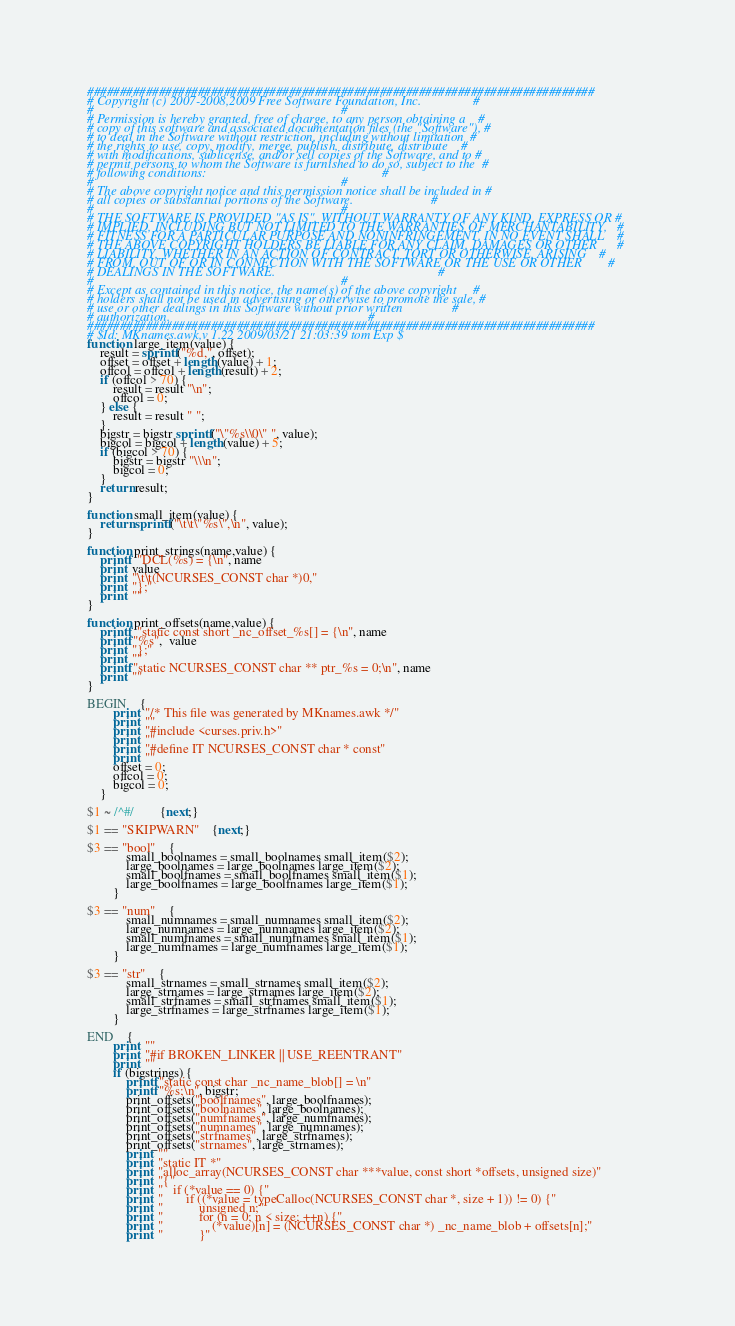Convert code to text. <code><loc_0><loc_0><loc_500><loc_500><_Awk_>##############################################################################
# Copyright (c) 2007-2008,2009 Free Software Foundation, Inc.                #
#                                                                            #
# Permission is hereby granted, free of charge, to any person obtaining a    #
# copy of this software and associated documentation files (the "Software"), #
# to deal in the Software without restriction, including without limitation  #
# the rights to use, copy, modify, merge, publish, distribute, distribute    #
# with modifications, sublicense, and/or sell copies of the Software, and to #
# permit persons to whom the Software is furnished to do so, subject to the  #
# following conditions:                                                      #
#                                                                            #
# The above copyright notice and this permission notice shall be included in #
# all copies or substantial portions of the Software.                        #
#                                                                            #
# THE SOFTWARE IS PROVIDED "AS IS", WITHOUT WARRANTY OF ANY KIND, EXPRESS OR #
# IMPLIED, INCLUDING BUT NOT LIMITED TO THE WARRANTIES OF MERCHANTABILITY,   #
# FITNESS FOR A PARTICULAR PURPOSE AND NONINFRINGEMENT. IN NO EVENT SHALL    #
# THE ABOVE COPYRIGHT HOLDERS BE LIABLE FOR ANY CLAIM, DAMAGES OR OTHER      #
# LIABILITY, WHETHER IN AN ACTION OF CONTRACT, TORT OR OTHERWISE, ARISING    #
# FROM, OUT OF OR IN CONNECTION WITH THE SOFTWARE OR THE USE OR OTHER        #
# DEALINGS IN THE SOFTWARE.                                                  #
#                                                                            #
# Except as contained in this notice, the name(s) of the above copyright     #
# holders shall not be used in advertising or otherwise to promote the sale, #
# use or other dealings in this Software without prior written               #
# authorization.                                                             #
##############################################################################
# $Id: MKnames.awk,v 1.22 2009/03/21 21:03:39 tom Exp $
function large_item(value) {
	result = sprintf("%d,", offset);
	offset = offset + length(value) + 1;
	offcol = offcol + length(result) + 2;
	if (offcol > 70) {
		result = result "\n";
		offcol = 0;
	} else {
		result = result " ";
	}
	bigstr = bigstr sprintf("\"%s\\0\" ", value);
	bigcol = bigcol + length(value) + 5;
	if (bigcol > 70) {
		bigstr = bigstr "\\\n";
		bigcol = 0;
	}
	return result;
}

function small_item(value) {
	return sprintf("\t\t\"%s\",\n", value);
}

function print_strings(name,value) {
	printf  "DCL(%s) = {\n", name
	print  value
	print  "\t\t(NCURSES_CONST char *)0,"
	print  "};"
	print  ""
}

function print_offsets(name,value) {
	printf  "static const short _nc_offset_%s[] = {\n", name
	printf "%s",  value
	print  "};"
	print  ""
	printf "static NCURSES_CONST char ** ptr_%s = 0;\n", name
	print  ""
}

BEGIN	{
		print  "/* This file was generated by MKnames.awk */"
		print  ""
		print  "#include <curses.priv.h>"
		print  ""
		print  "#define IT NCURSES_CONST char * const"
		print  ""
		offset = 0;
		offcol = 0;
		bigcol = 0;
	}

$1 ~ /^#/		{next;}

$1 == "SKIPWARN"	{next;}

$3 == "bool"	{
			small_boolnames = small_boolnames small_item($2);
			large_boolnames = large_boolnames large_item($2);
			small_boolfnames = small_boolfnames small_item($1);
			large_boolfnames = large_boolfnames large_item($1);
		}

$3 == "num"	{
			small_numnames = small_numnames small_item($2);
			large_numnames = large_numnames large_item($2);
			small_numfnames = small_numfnames small_item($1);
			large_numfnames = large_numfnames large_item($1);
		}

$3 == "str"	{
			small_strnames = small_strnames small_item($2);
			large_strnames = large_strnames large_item($2);
			small_strfnames = small_strfnames small_item($1);
			large_strfnames = large_strfnames large_item($1);
		}

END	{
		print  ""
		print  "#if BROKEN_LINKER || USE_REENTRANT"
		print  ""
		if (bigstrings) {
			printf "static const char _nc_name_blob[] = \n"
			printf "%s;\n", bigstr;
			print_offsets("boolfnames", large_boolfnames);
			print_offsets("boolnames", large_boolnames);
			print_offsets("numfnames", large_numfnames);
			print_offsets("numnames", large_numnames);
			print_offsets("strfnames", large_strfnames);
			print_offsets("strnames", large_strnames);
			print  ""
			print  "static IT *"
			print  "alloc_array(NCURSES_CONST char ***value, const short *offsets, unsigned size)"
			print  "{"
			print  "	if (*value == 0) {"
			print  "		if ((*value = typeCalloc(NCURSES_CONST char *, size + 1)) != 0) {"
			print  "			unsigned n;"
			print  "			for (n = 0; n < size; ++n) {"
			print  "				(*value)[n] = (NCURSES_CONST char *) _nc_name_blob + offsets[n];"
			print  "			}"</code> 